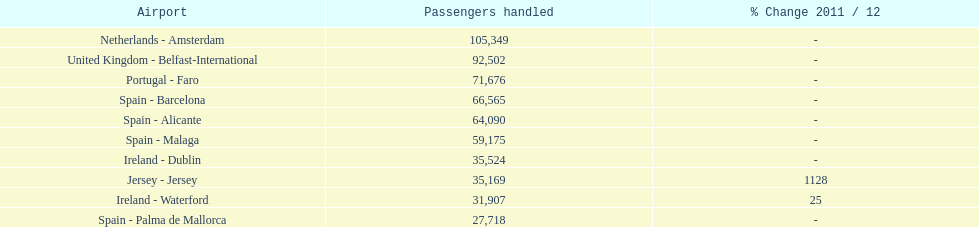Which airport has no more than 30,000 passengers handled among the 10 busiest routes to and from london southend airport in 2012? Spain - Palma de Mallorca. 